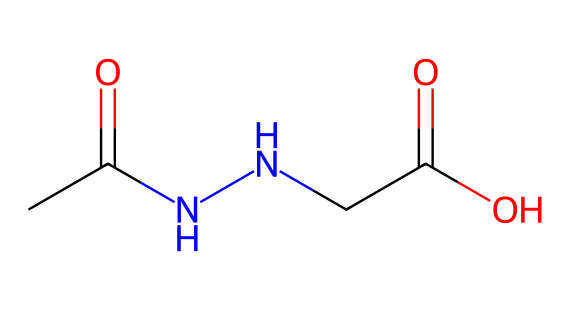What is the main functional group present in daminozide? The chemical structure has a carbonyl group (C=O) indicative of an amide and a carboxylic acid. The presence of the -C(=O)-N- linkage highlights the main functional group, which is an amide.
Answer: amide How many nitrogen atoms are in daminozide? By examining the SMILES representation CC(=O)NNCC(=O)O, we can identify two nitrogen atoms (indicated by 'N'). Counting these confirms that there are two nitrogen atoms present.
Answer: two What is the molecular formula of daminozide? To deduce the molecular formula, count the atoms in the SMILES representation: 5 carbon (C), 8 hydrogen (H), 2 nitrogen (N), and 3 oxygen (O) leads to the formula C5H8N2O3.
Answer: C5H8N2O3 What type of chemical is daminozide classified as? Given its structure contains hydrazine and is specifically used as a plant growth retardant, daminozide is classified as a hydrazine derivative.
Answer: hydrazine derivative Which part of the chemical indicates its role as a growth retardant? The presence of carbonyl groups adjacent to nitrogen within the hydrazine framework suggests its physiological activity in inhibiting plant growth, a characteristic of growth retardants. The specific functional relationships in this structure contribute to its effectiveness in horticulture.
Answer: carbonyl groups Does daminozide contain any acidic functional groups? Yes, the presence of the -COOH group indicates a carboxylic acid functional group, which is characterized by its acidic nature due to the ability to donate a proton (H+).
Answer: yes 